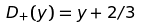Convert formula to latex. <formula><loc_0><loc_0><loc_500><loc_500>D _ { + } ( y ) = y + 2 / 3</formula> 